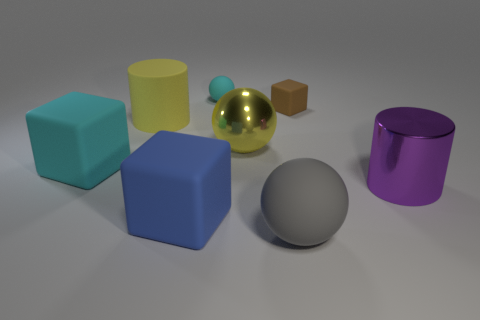Add 2 big yellow metallic blocks. How many objects exist? 10 Subtract all cylinders. How many objects are left? 6 Subtract all large purple matte things. Subtract all cyan objects. How many objects are left? 6 Add 6 metal cylinders. How many metal cylinders are left? 7 Add 8 small cyan rubber spheres. How many small cyan rubber spheres exist? 9 Subtract 0 gray cubes. How many objects are left? 8 